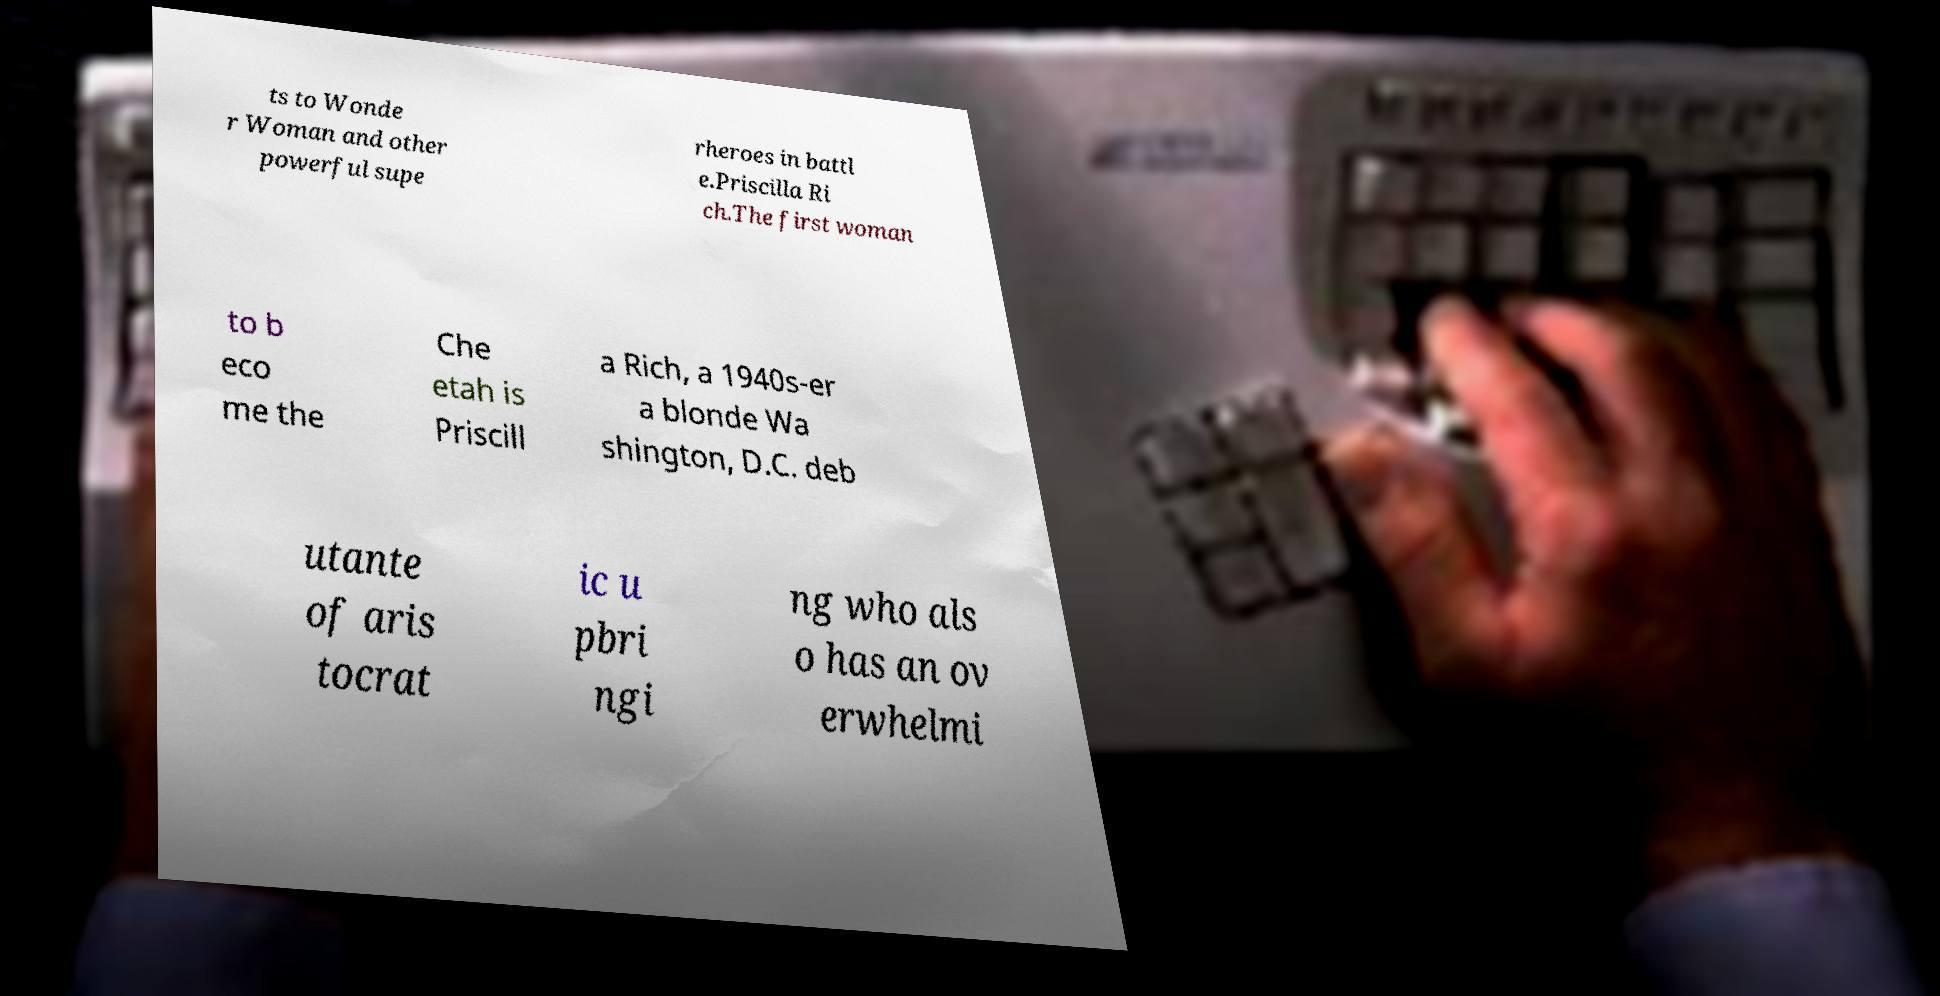For documentation purposes, I need the text within this image transcribed. Could you provide that? ts to Wonde r Woman and other powerful supe rheroes in battl e.Priscilla Ri ch.The first woman to b eco me the Che etah is Priscill a Rich, a 1940s-er a blonde Wa shington, D.C. deb utante of aris tocrat ic u pbri ngi ng who als o has an ov erwhelmi 